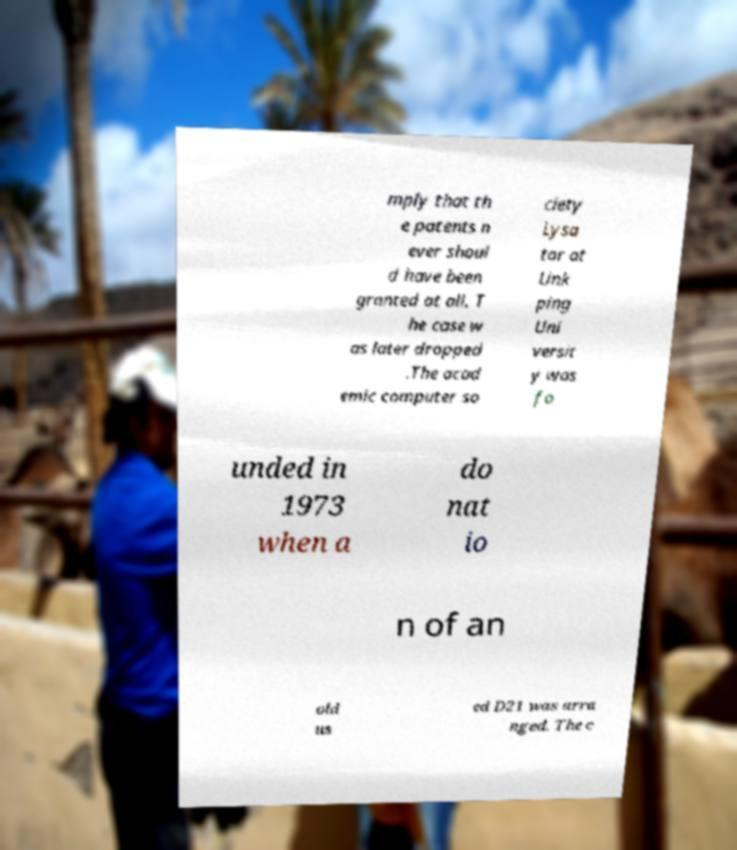Please read and relay the text visible in this image. What does it say? mply that th e patents n ever shoul d have been granted at all. T he case w as later dropped .The acad emic computer so ciety Lysa tor at Link ping Uni versit y was fo unded in 1973 when a do nat io n of an old us ed D21 was arra nged. The c 